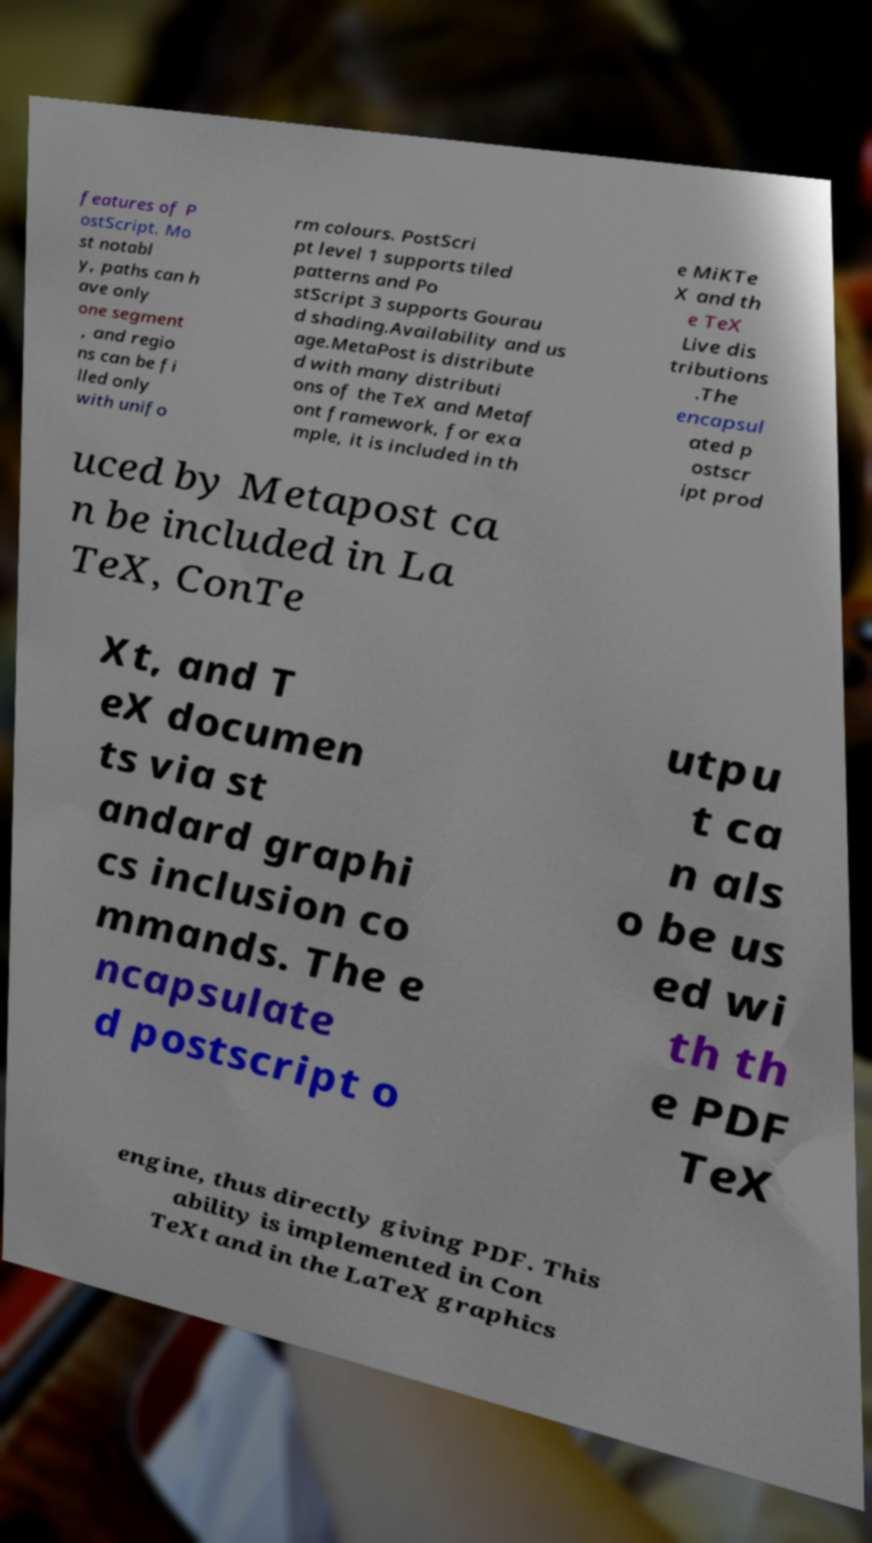Could you assist in decoding the text presented in this image and type it out clearly? features of P ostScript. Mo st notabl y, paths can h ave only one segment , and regio ns can be fi lled only with unifo rm colours. PostScri pt level 1 supports tiled patterns and Po stScript 3 supports Gourau d shading.Availability and us age.MetaPost is distribute d with many distributi ons of the TeX and Metaf ont framework, for exa mple, it is included in th e MiKTe X and th e TeX Live dis tributions .The encapsul ated p ostscr ipt prod uced by Metapost ca n be included in La TeX, ConTe Xt, and T eX documen ts via st andard graphi cs inclusion co mmands. The e ncapsulate d postscript o utpu t ca n als o be us ed wi th th e PDF TeX engine, thus directly giving PDF. This ability is implemented in Con TeXt and in the LaTeX graphics 